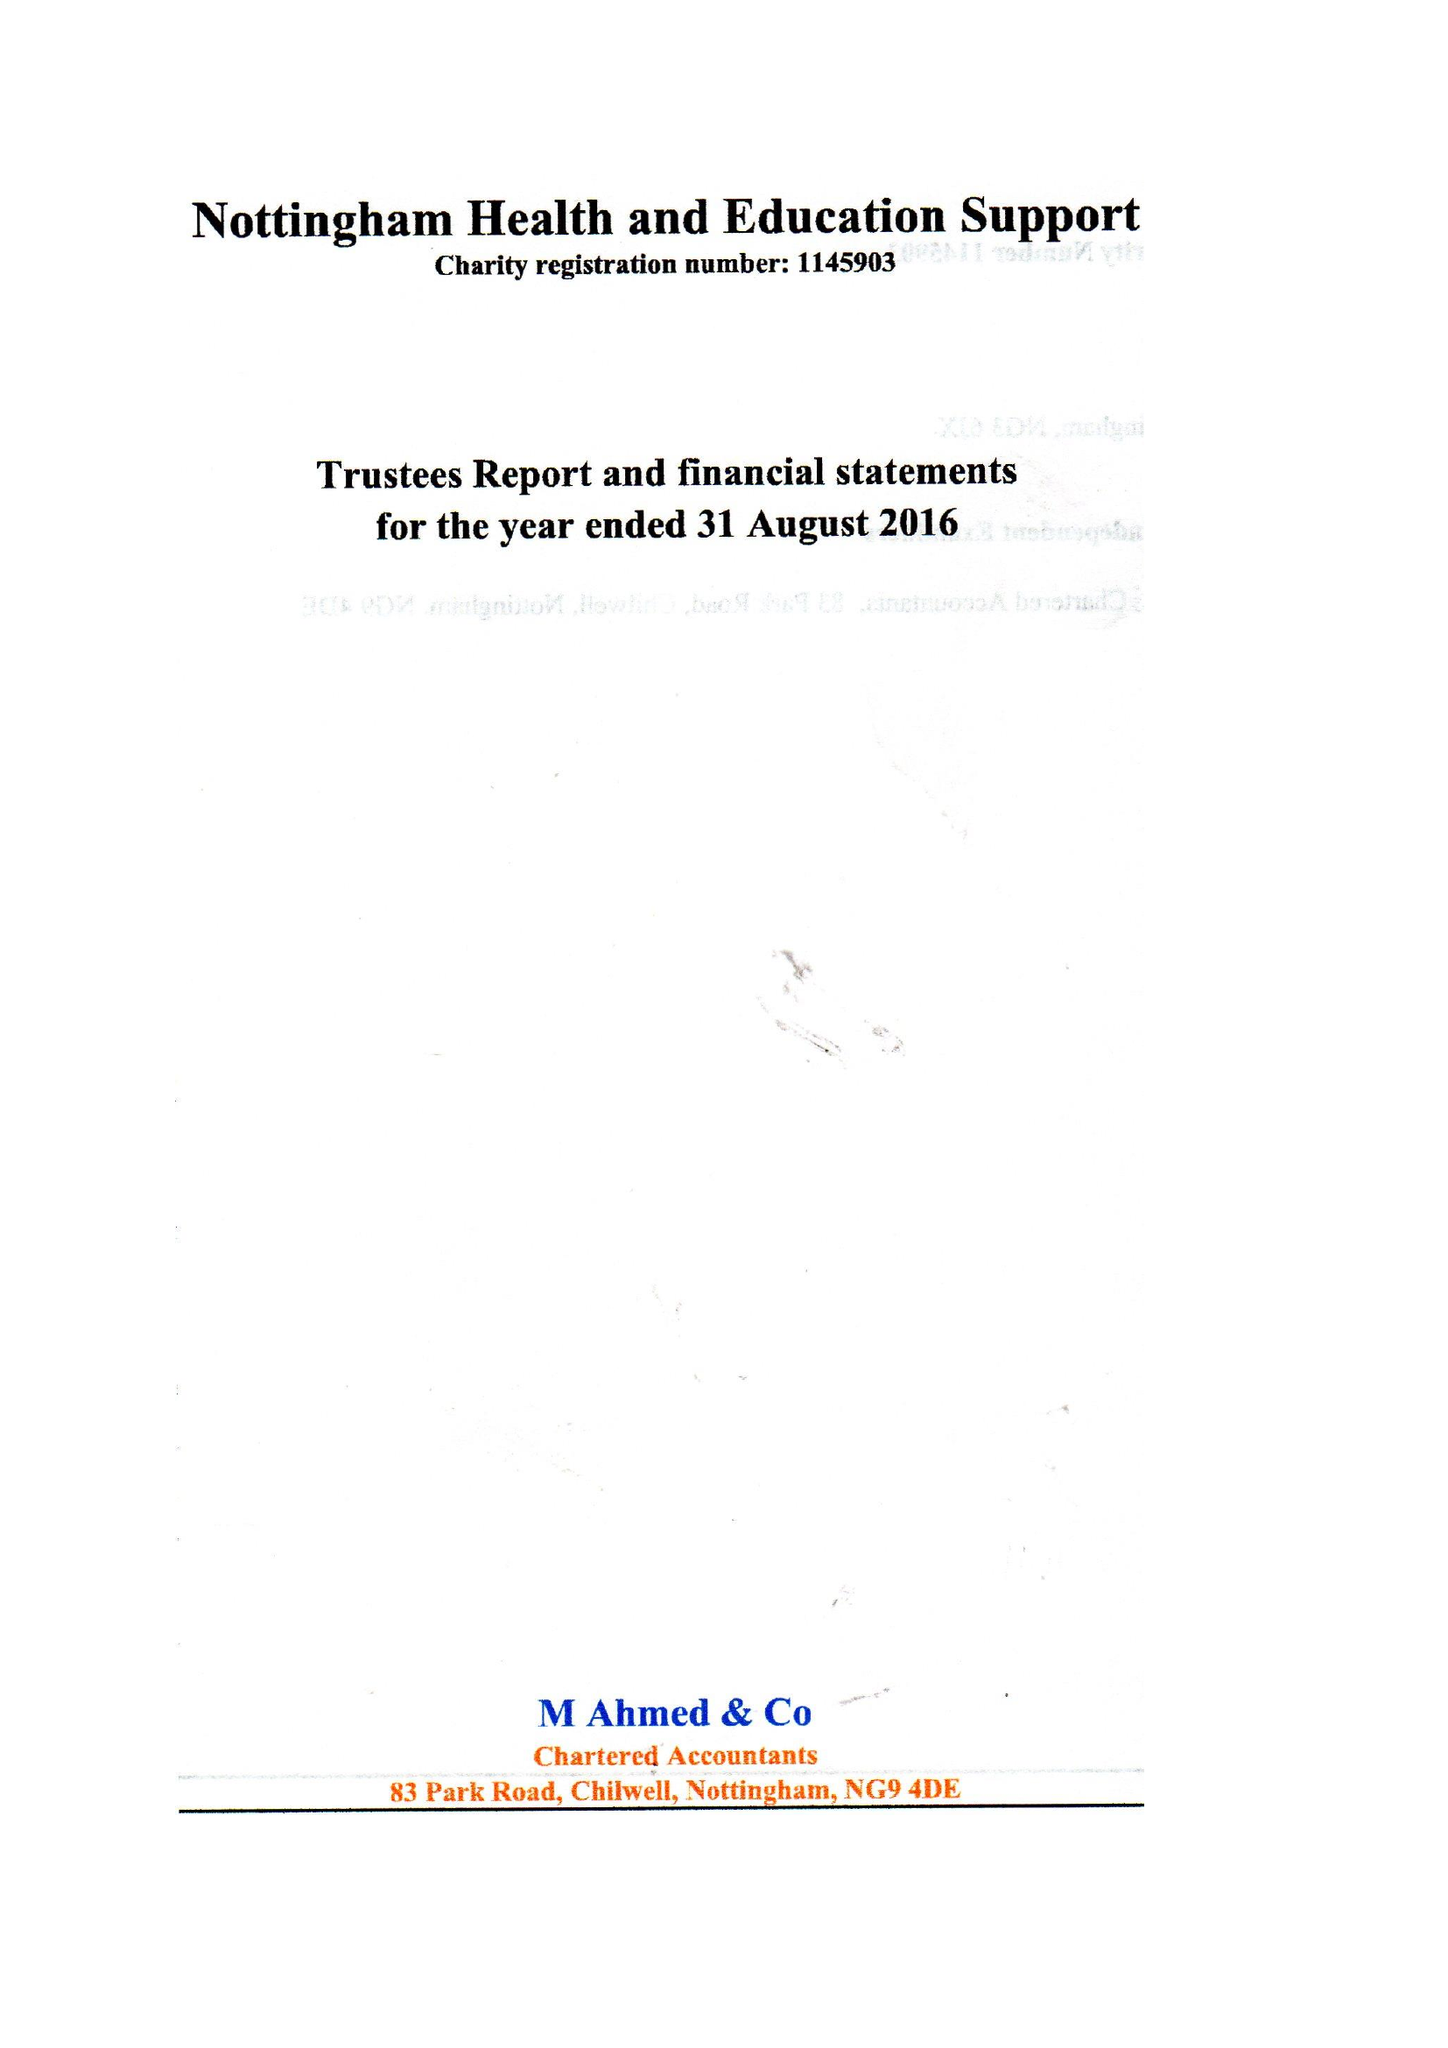What is the value for the address__postcode?
Answer the question using a single word or phrase. NG3 6JX 